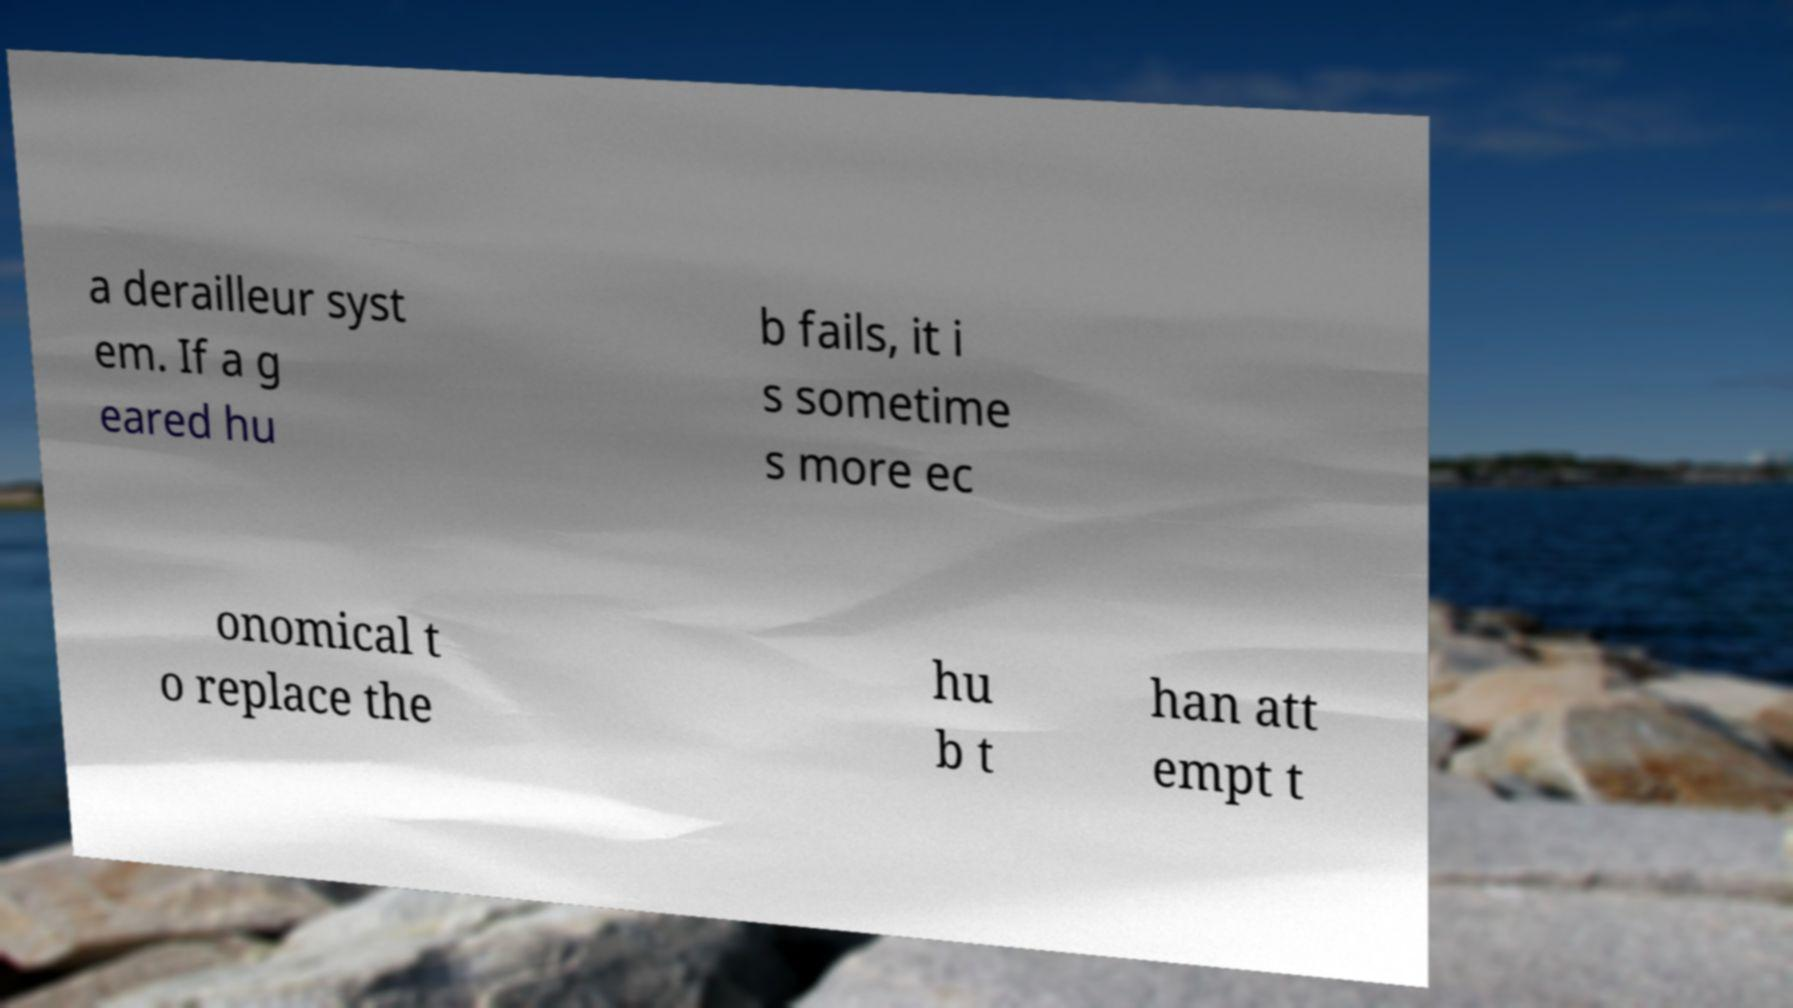Please read and relay the text visible in this image. What does it say? a derailleur syst em. If a g eared hu b fails, it i s sometime s more ec onomical t o replace the hu b t han att empt t 